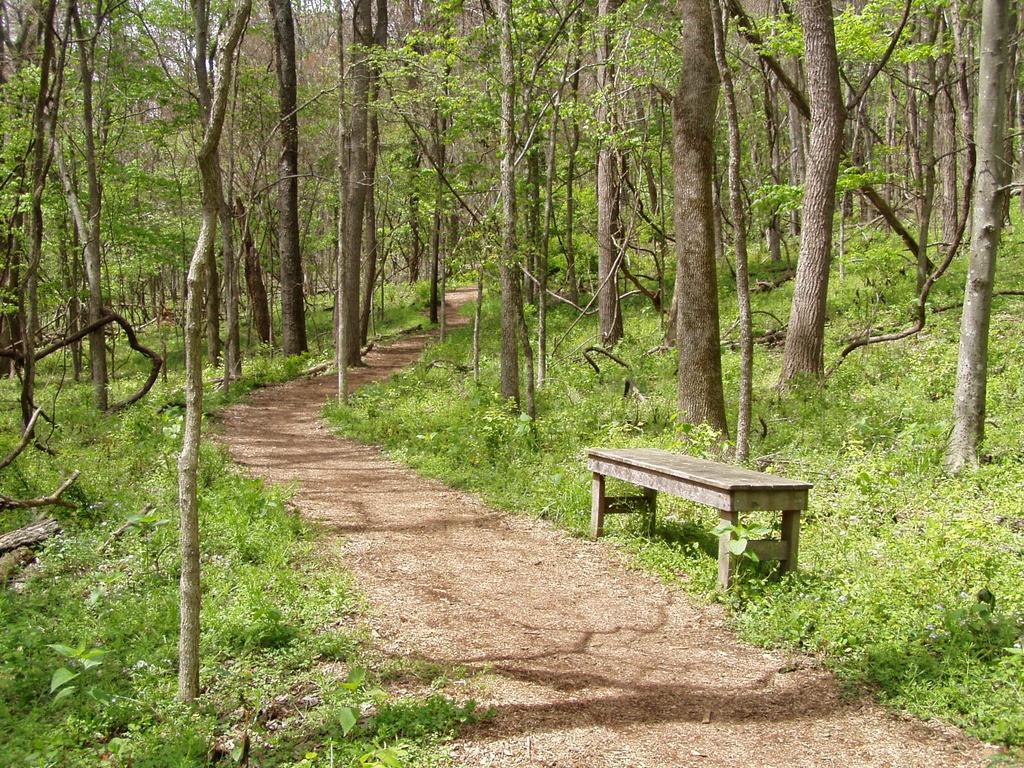Please provide a concise description of this image. This picture shows few trees and a bench on the side and we see plants on the ground and a path. 